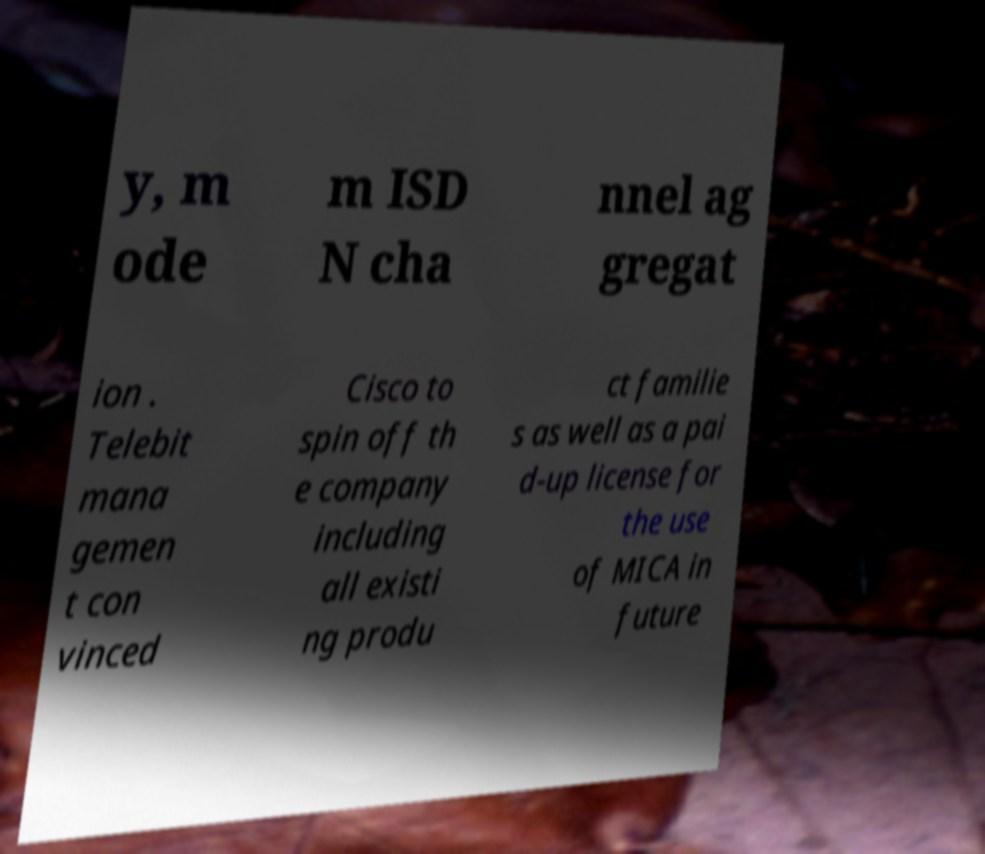Could you extract and type out the text from this image? y, m ode m ISD N cha nnel ag gregat ion . Telebit mana gemen t con vinced Cisco to spin off th e company including all existi ng produ ct familie s as well as a pai d-up license for the use of MICA in future 